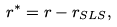<formula> <loc_0><loc_0><loc_500><loc_500>r ^ { * } = r - r _ { S L S } ,</formula> 